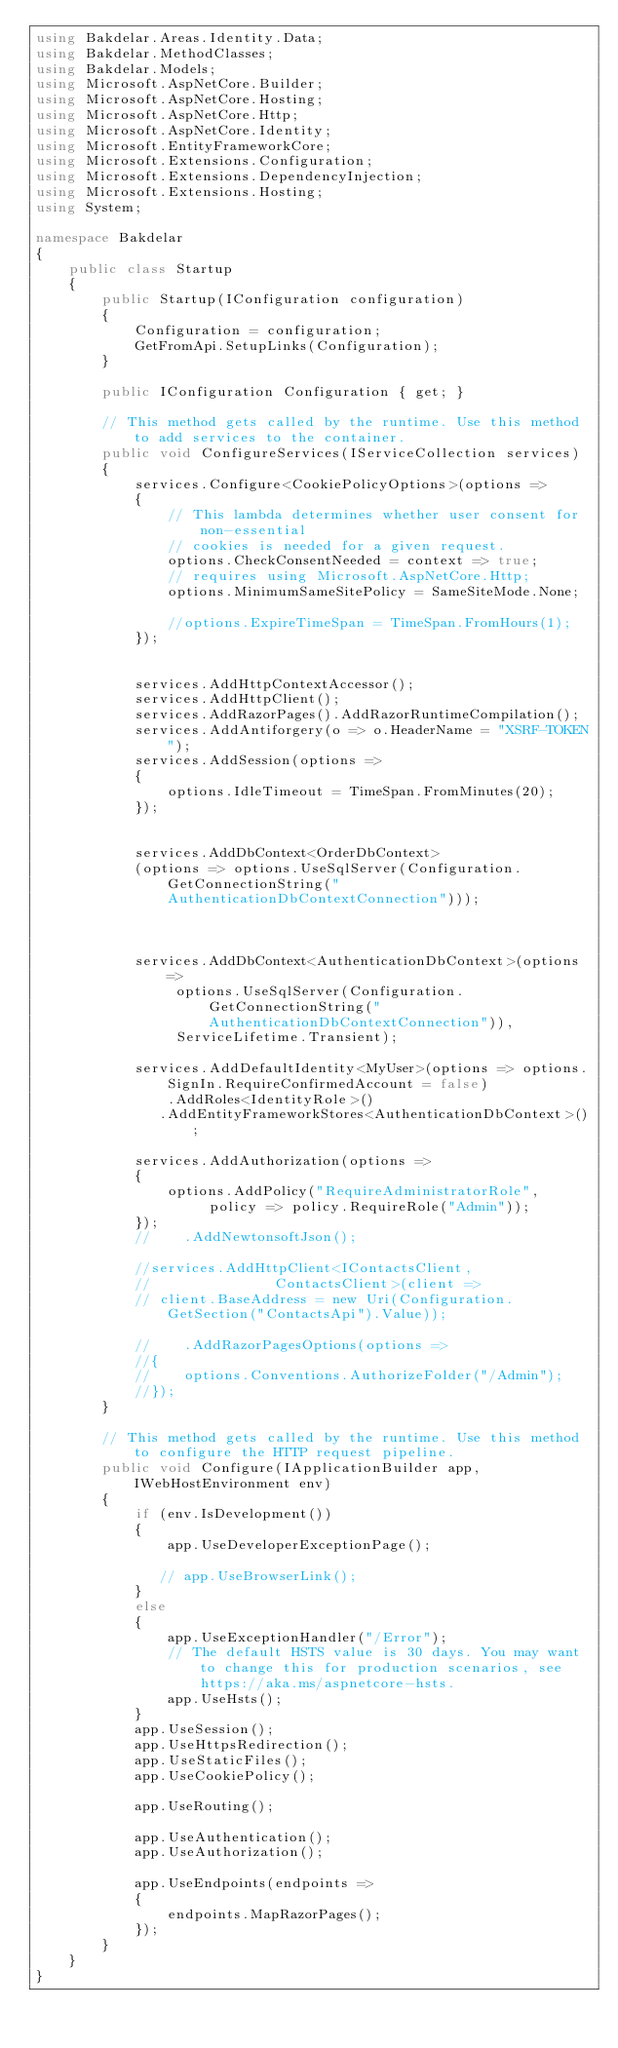Convert code to text. <code><loc_0><loc_0><loc_500><loc_500><_C#_>using Bakdelar.Areas.Identity.Data;
using Bakdelar.MethodClasses;
using Bakdelar.Models;
using Microsoft.AspNetCore.Builder;
using Microsoft.AspNetCore.Hosting;
using Microsoft.AspNetCore.Http;
using Microsoft.AspNetCore.Identity;
using Microsoft.EntityFrameworkCore;
using Microsoft.Extensions.Configuration;
using Microsoft.Extensions.DependencyInjection;
using Microsoft.Extensions.Hosting;
using System;

namespace Bakdelar
{
    public class Startup
    {
        public Startup(IConfiguration configuration)
        {
            Configuration = configuration;
            GetFromApi.SetupLinks(Configuration);
        }

        public IConfiguration Configuration { get; }

        // This method gets called by the runtime. Use this method to add services to the container.
        public void ConfigureServices(IServiceCollection services)
        {
            services.Configure<CookiePolicyOptions>(options =>
            {
                // This lambda determines whether user consent for non-essential 
                // cookies is needed for a given request.
                options.CheckConsentNeeded = context => true;
                // requires using Microsoft.AspNetCore.Http;
                options.MinimumSameSitePolicy = SameSiteMode.None;

                //options.ExpireTimeSpan = TimeSpan.FromHours(1);
            });


            services.AddHttpContextAccessor();
            services.AddHttpClient();
            services.AddRazorPages().AddRazorRuntimeCompilation();
            services.AddAntiforgery(o => o.HeaderName = "XSRF-TOKEN");
            services.AddSession(options =>
            {
                options.IdleTimeout = TimeSpan.FromMinutes(20);
            });


            services.AddDbContext<OrderDbContext>
            (options => options.UseSqlServer(Configuration.GetConnectionString("AuthenticationDbContextConnection")));



            services.AddDbContext<AuthenticationDbContext>(options =>
                 options.UseSqlServer(Configuration.GetConnectionString("AuthenticationDbContextConnection")),
                 ServiceLifetime.Transient);

            services.AddDefaultIdentity<MyUser>(options => options.SignIn.RequireConfirmedAccount = false)
                .AddRoles<IdentityRole>()
               .AddEntityFrameworkStores<AuthenticationDbContext>();

            services.AddAuthorization(options =>
            {
                options.AddPolicy("RequireAdministratorRole",
                     policy => policy.RequireRole("Admin"));
            });
            //    .AddNewtonsoftJson();

            //services.AddHttpClient<IContactsClient,
            //               ContactsClient>(client =>
            // client.BaseAddress = new Uri(Configuration.GetSection("ContactsApi").Value));

            //    .AddRazorPagesOptions(options =>
            //{
            //    options.Conventions.AuthorizeFolder("/Admin");
            //});
        }

        // This method gets called by the runtime. Use this method to configure the HTTP request pipeline.
        public void Configure(IApplicationBuilder app, IWebHostEnvironment env)
        {
            if (env.IsDevelopment())
            {
                app.UseDeveloperExceptionPage();

               // app.UseBrowserLink();
            }
            else
            {
                app.UseExceptionHandler("/Error");
                // The default HSTS value is 30 days. You may want to change this for production scenarios, see https://aka.ms/aspnetcore-hsts.
                app.UseHsts();
            }
            app.UseSession();
            app.UseHttpsRedirection();
            app.UseStaticFiles();
            app.UseCookiePolicy();

            app.UseRouting();

            app.UseAuthentication();
            app.UseAuthorization();

            app.UseEndpoints(endpoints =>
            {
                endpoints.MapRazorPages();
            });
        }
    }
}
</code> 